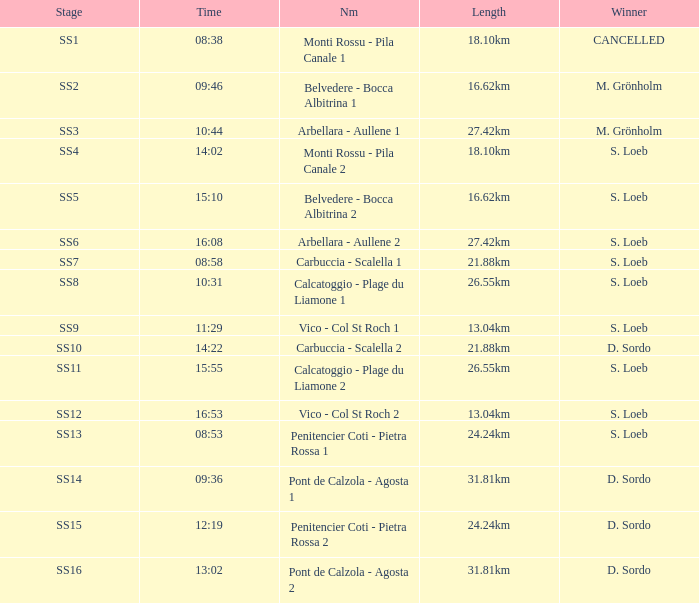Give me the full table as a dictionary. {'header': ['Stage', 'Time', 'Nm', 'Length', 'Winner'], 'rows': [['SS1', '08:38', 'Monti Rossu - Pila Canale 1', '18.10km', 'CANCELLED'], ['SS2', '09:46', 'Belvedere - Bocca Albitrina 1', '16.62km', 'M. Grönholm'], ['SS3', '10:44', 'Arbellara - Aullene 1', '27.42km', 'M. Grönholm'], ['SS4', '14:02', 'Monti Rossu - Pila Canale 2', '18.10km', 'S. Loeb'], ['SS5', '15:10', 'Belvedere - Bocca Albitrina 2', '16.62km', 'S. Loeb'], ['SS6', '16:08', 'Arbellara - Aullene 2', '27.42km', 'S. Loeb'], ['SS7', '08:58', 'Carbuccia - Scalella 1', '21.88km', 'S. Loeb'], ['SS8', '10:31', 'Calcatoggio - Plage du Liamone 1', '26.55km', 'S. Loeb'], ['SS9', '11:29', 'Vico - Col St Roch 1', '13.04km', 'S. Loeb'], ['SS10', '14:22', 'Carbuccia - Scalella 2', '21.88km', 'D. Sordo'], ['SS11', '15:55', 'Calcatoggio - Plage du Liamone 2', '26.55km', 'S. Loeb'], ['SS12', '16:53', 'Vico - Col St Roch 2', '13.04km', 'S. Loeb'], ['SS13', '08:53', 'Penitencier Coti - Pietra Rossa 1', '24.24km', 'S. Loeb'], ['SS14', '09:36', 'Pont de Calzola - Agosta 1', '31.81km', 'D. Sordo'], ['SS15', '12:19', 'Penitencier Coti - Pietra Rossa 2', '24.24km', 'D. Sordo'], ['SS16', '13:02', 'Pont de Calzola - Agosta 2', '31.81km', 'D. Sordo']]} What is the Name of the SS11 Stage? Calcatoggio - Plage du Liamone 2. 